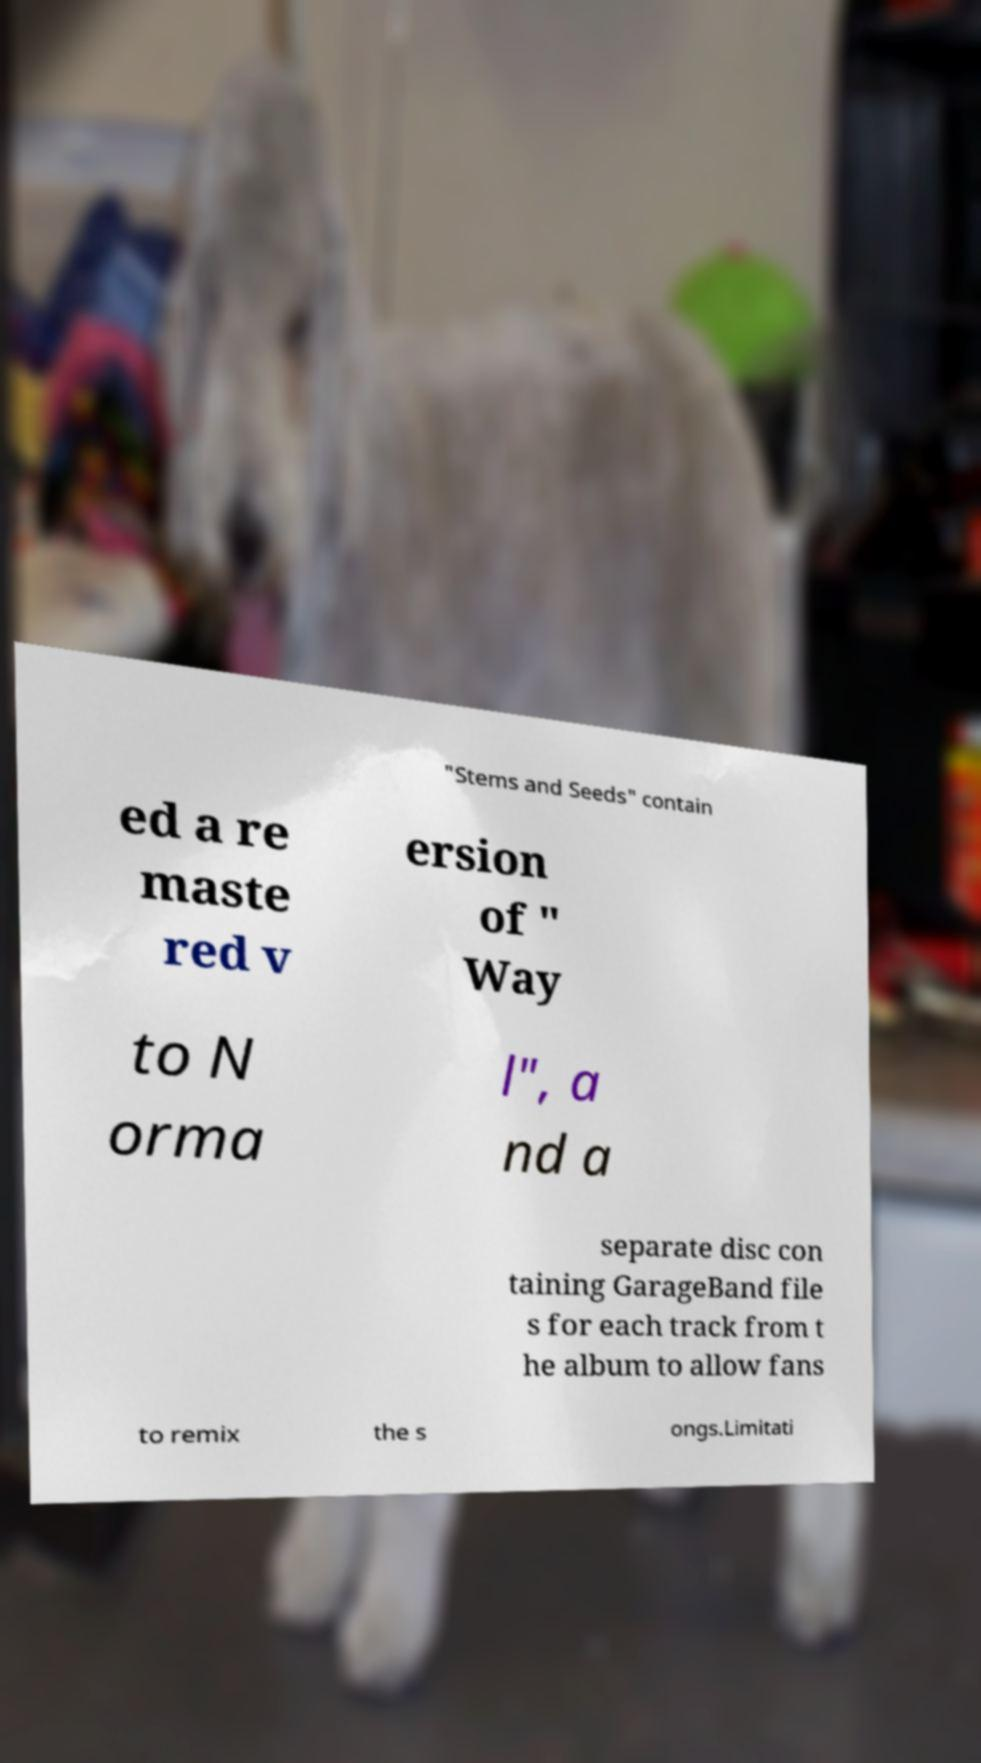I need the written content from this picture converted into text. Can you do that? "Stems and Seeds" contain ed a re maste red v ersion of " Way to N orma l", a nd a separate disc con taining GarageBand file s for each track from t he album to allow fans to remix the s ongs.Limitati 